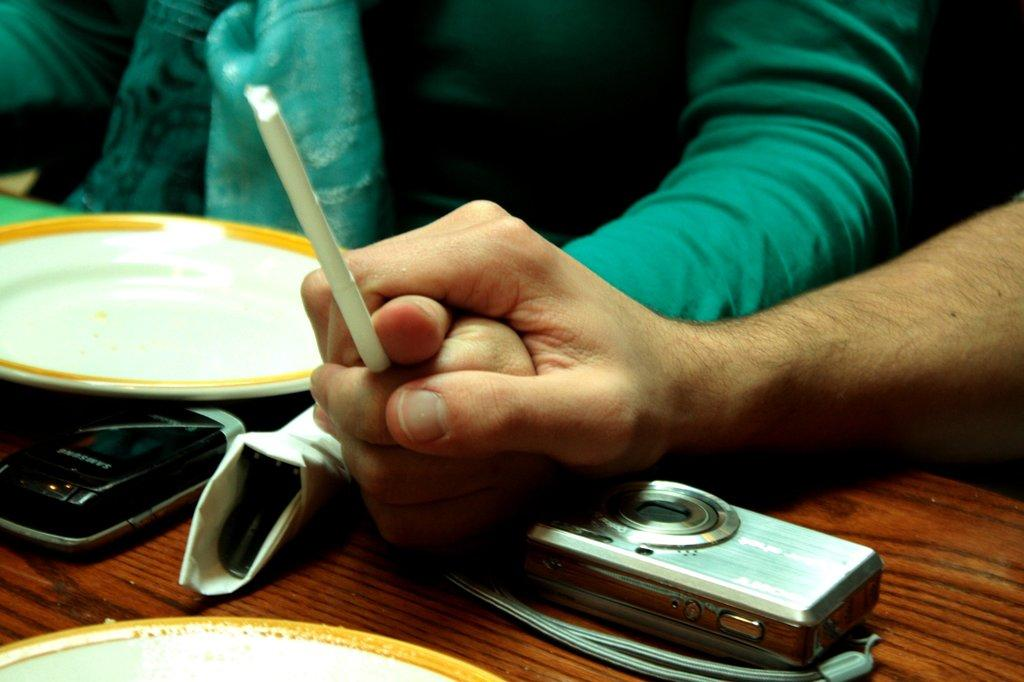What is happening between the two people in the image? There is a person holding another person's hand in the image. What objects are on the table in the image? There is a camera, a mobile phone, and a plate on the table. What type of mask is the person wearing in the image? There is no mask present in the image; the person is simply holding another person's hand. 